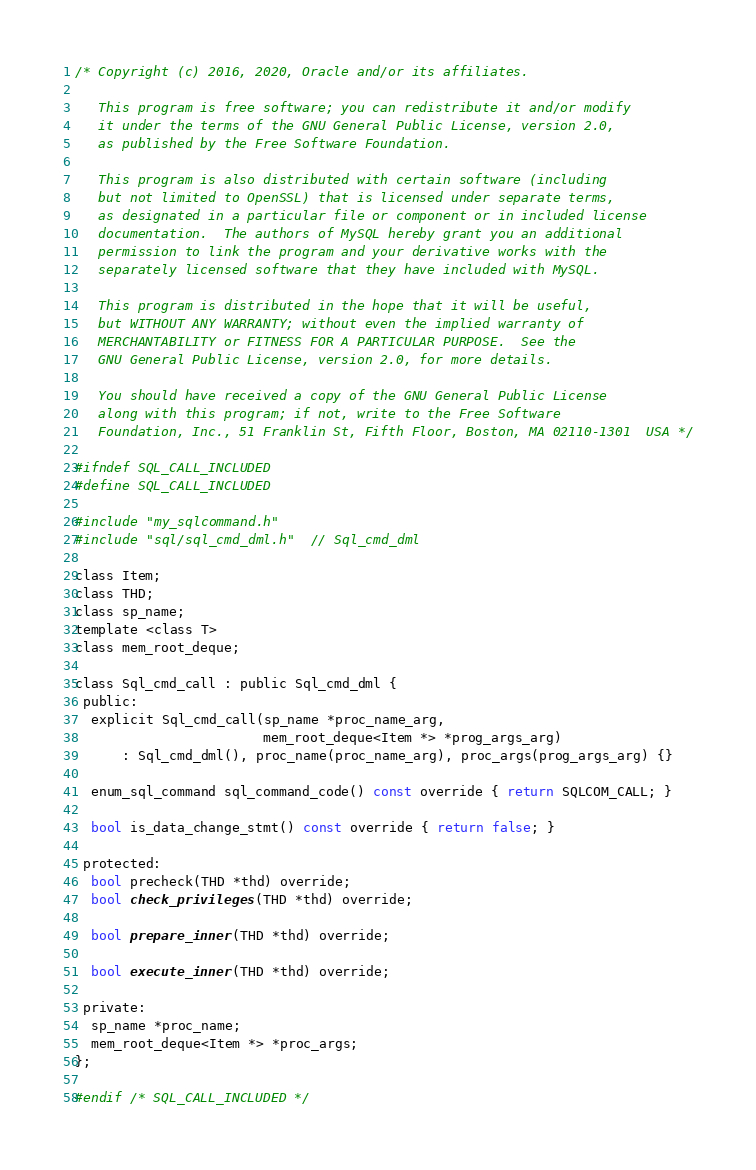Convert code to text. <code><loc_0><loc_0><loc_500><loc_500><_C_>/* Copyright (c) 2016, 2020, Oracle and/or its affiliates.

   This program is free software; you can redistribute it and/or modify
   it under the terms of the GNU General Public License, version 2.0,
   as published by the Free Software Foundation.

   This program is also distributed with certain software (including
   but not limited to OpenSSL) that is licensed under separate terms,
   as designated in a particular file or component or in included license
   documentation.  The authors of MySQL hereby grant you an additional
   permission to link the program and your derivative works with the
   separately licensed software that they have included with MySQL.

   This program is distributed in the hope that it will be useful,
   but WITHOUT ANY WARRANTY; without even the implied warranty of
   MERCHANTABILITY or FITNESS FOR A PARTICULAR PURPOSE.  See the
   GNU General Public License, version 2.0, for more details.

   You should have received a copy of the GNU General Public License
   along with this program; if not, write to the Free Software
   Foundation, Inc., 51 Franklin St, Fifth Floor, Boston, MA 02110-1301  USA */

#ifndef SQL_CALL_INCLUDED
#define SQL_CALL_INCLUDED

#include "my_sqlcommand.h"
#include "sql/sql_cmd_dml.h"  // Sql_cmd_dml

class Item;
class THD;
class sp_name;
template <class T>
class mem_root_deque;

class Sql_cmd_call : public Sql_cmd_dml {
 public:
  explicit Sql_cmd_call(sp_name *proc_name_arg,
                        mem_root_deque<Item *> *prog_args_arg)
      : Sql_cmd_dml(), proc_name(proc_name_arg), proc_args(prog_args_arg) {}

  enum_sql_command sql_command_code() const override { return SQLCOM_CALL; }

  bool is_data_change_stmt() const override { return false; }

 protected:
  bool precheck(THD *thd) override;
  bool check_privileges(THD *thd) override;

  bool prepare_inner(THD *thd) override;

  bool execute_inner(THD *thd) override;

 private:
  sp_name *proc_name;
  mem_root_deque<Item *> *proc_args;
};

#endif /* SQL_CALL_INCLUDED */
</code> 